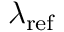<formula> <loc_0><loc_0><loc_500><loc_500>\lambda _ { r e f }</formula> 